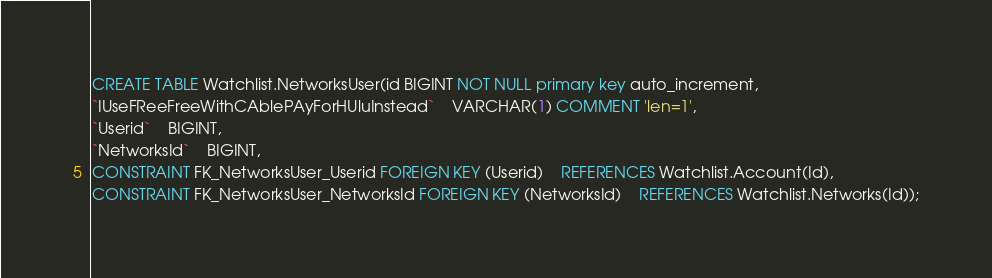Convert code to text. <code><loc_0><loc_0><loc_500><loc_500><_SQL_>CREATE TABLE Watchlist.NetworksUser(id BIGINT NOT NULL primary key auto_increment,
`IUseFReeFreeWithCAblePAyForHUluInstead`	VARCHAR(1) COMMENT 'len=1',
`Userid`	BIGINT,
`NetworksId`	BIGINT,
CONSTRAINT FK_NetworksUser_Userid FOREIGN KEY (Userid)    REFERENCES Watchlist.Account(Id),
CONSTRAINT FK_NetworksUser_NetworksId FOREIGN KEY (NetworksId)    REFERENCES Watchlist.Networks(Id));
</code> 